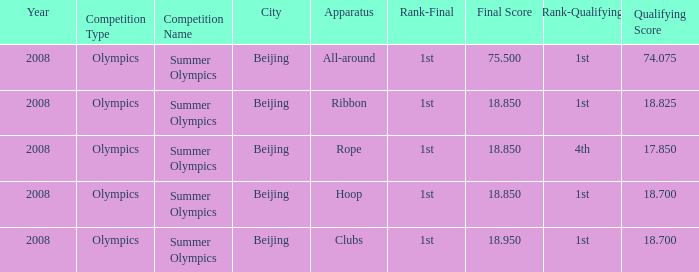What was her lowest final score with a qualifying score of 74.075? 75.5. 